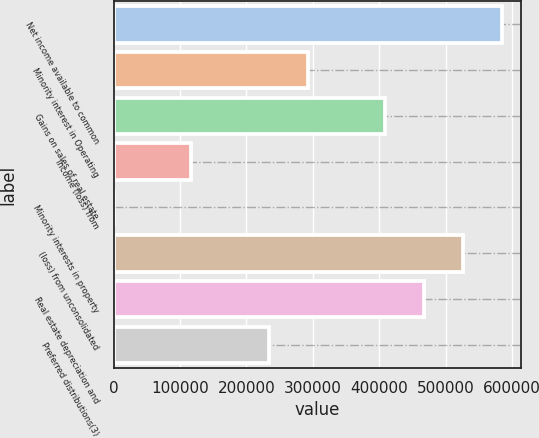Convert chart. <chart><loc_0><loc_0><loc_500><loc_500><bar_chart><fcel>Net income available to common<fcel>Minority interest in Operating<fcel>Gains on sales of real estate<fcel>Income (loss) from<fcel>Minority interests in property<fcel>(loss) from unconsolidated<fcel>Real estate depreciation and<fcel>Preferred distributions(3)<nl><fcel>583918<fcel>292016<fcel>408776<fcel>116874<fcel>113<fcel>525538<fcel>467157<fcel>233635<nl></chart> 